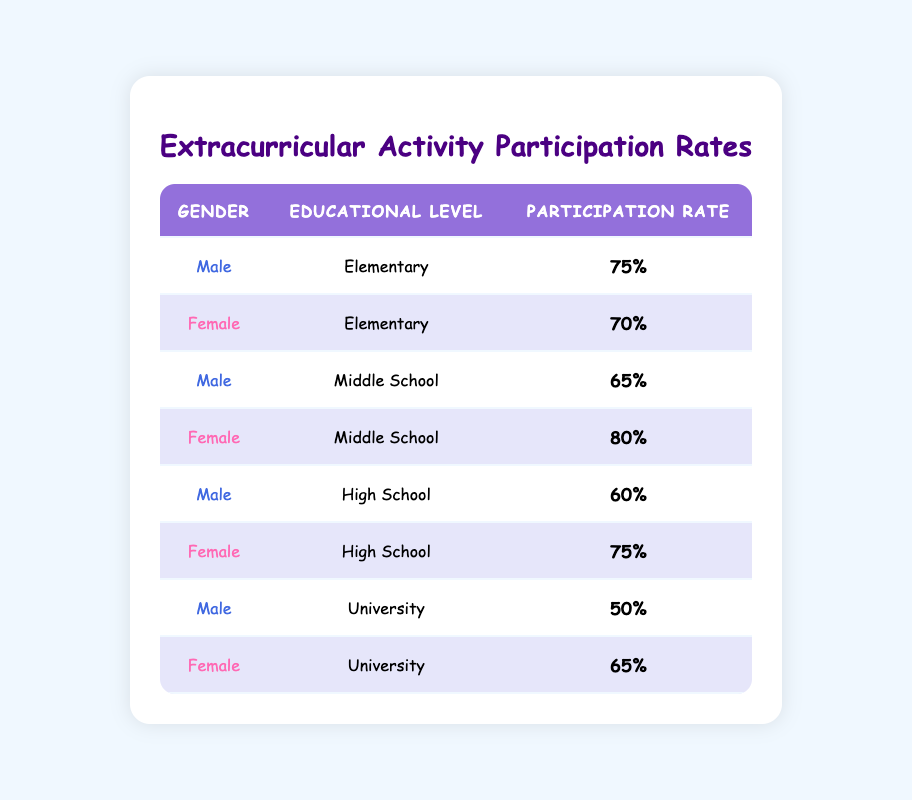What is the participation rate for Male students in Middle School? The table shows that the participation rate for Male students in Middle School is listed directly under that category, which states a rate of 65%.
Answer: 65% What is the participation rate for Female students in High School? Referring to the row for Female students in High School from the table, the participation rate is noted as 75%.
Answer: 75% Are Female students more involved in extracurricular activities at the Elementary level compared to Male students? By comparing the participation rates listed in the table, Female students have a participation rate of 70%, while Male students have a rate of 75%. Since 70% is less than 75%, the answer is no.
Answer: No What is the difference in participation rates between Female students in Middle School and Female students in High School? The participation rate for Female students in Middle School is 80%, and in High School, it is 75%. To find the difference, subtract 75 from 80, which gives 5.
Answer: 5% What is the average participation rate for Male students across all educational levels? The participation rates for Male students are 75% (Elementary), 65% (Middle School), 60% (High School), and 50% (University). First, sum these rates: 75 + 65 + 60 + 50 = 250. Then, divide by the number of educational levels (4): 250 / 4 = 62.5.
Answer: 62.5 Is the participation rate for Male students in University higher than the participation rate for Female students at the same level? The table shows that Male students have a participation rate of 50% in University while Female students have a rate of 65%. Since 50% is less than 65%, the answer is no.
Answer: No What are the overall participation rates for Female students across all levels, and what percentage of them are below 70%? The participation rates for Female students are 70% (Elementary), 80% (Middle School), 75% (High School), and 65% (University). 70% (Elementary), 75% (High School), and 80% (Middle School) are above 70%, while only 65% (University) is below. The single rate below 70% means 1 out of 4 rates is below this threshold.
Answer: 1 What is the maximum participation rate for Female students across all educational levels? The participation rates for Female students across educational levels are 70%, 80%, 75%, and 65%. The highest among these rates is 80%, found in Middle School.
Answer: 80% Is the participation rate for Male students in High School lower than the participation rate for Female students in University? The table indicates that the participation rate for Male students in High School is 60% while for Female students in University it is 65%. Since 60% is indeed lower than 65%, the answer confirmed is yes.
Answer: Yes 